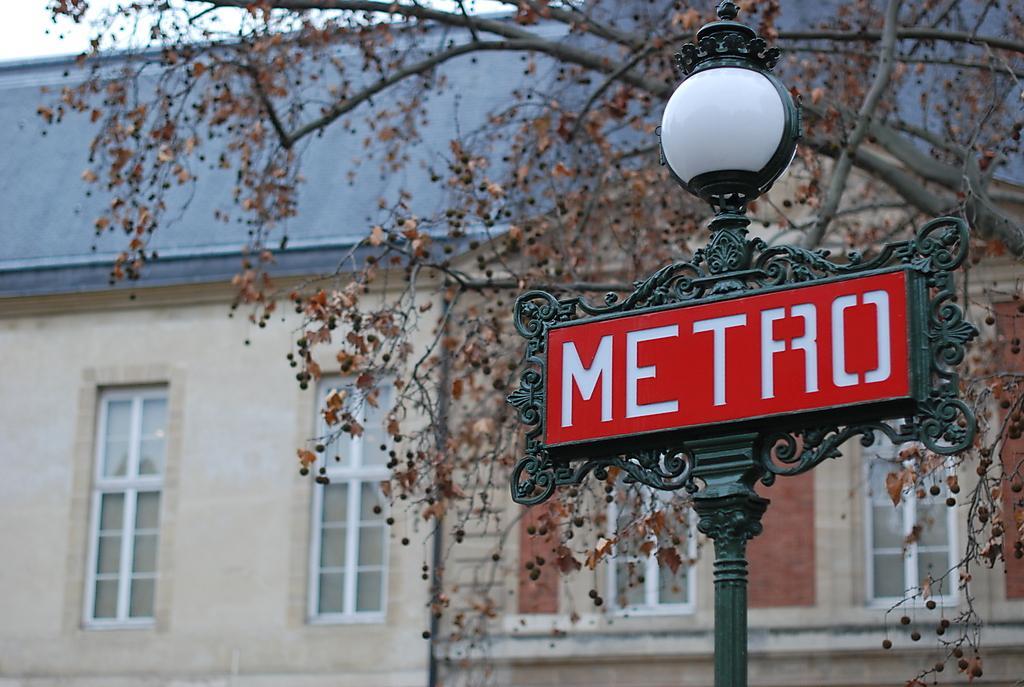Could you give a brief overview of what you see in this image? In the foreground I can see a light pole and board. In the background I can see a tree, house and windows. On the top left I can see the sky. This image is taken during a day. 